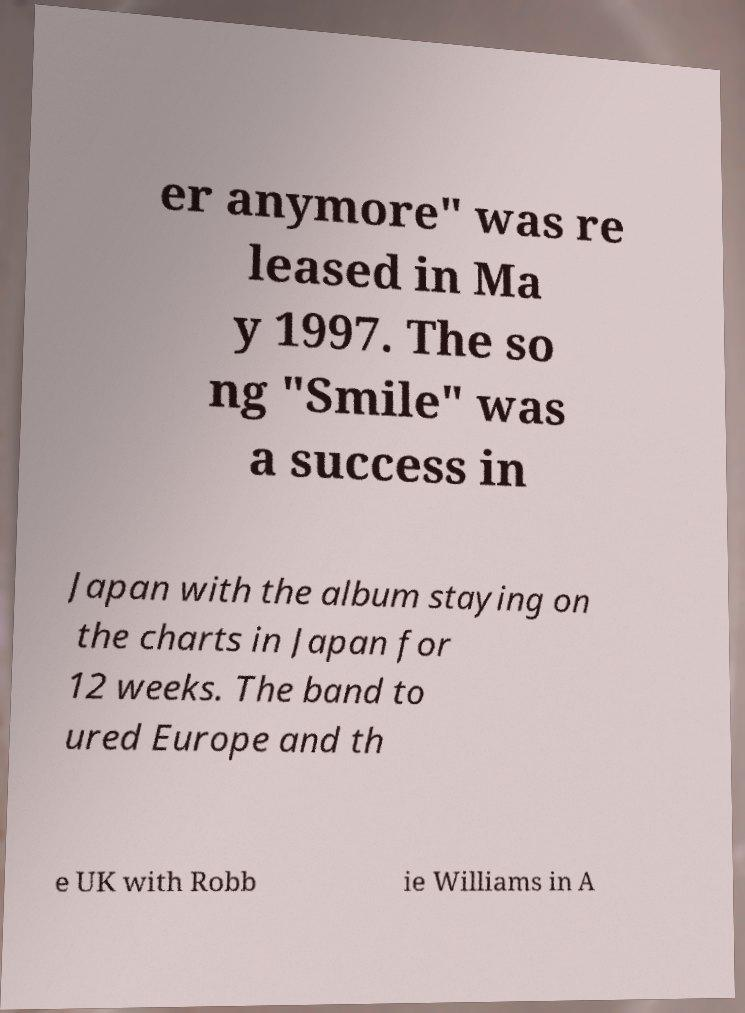Could you assist in decoding the text presented in this image and type it out clearly? er anymore" was re leased in Ma y 1997. The so ng "Smile" was a success in Japan with the album staying on the charts in Japan for 12 weeks. The band to ured Europe and th e UK with Robb ie Williams in A 